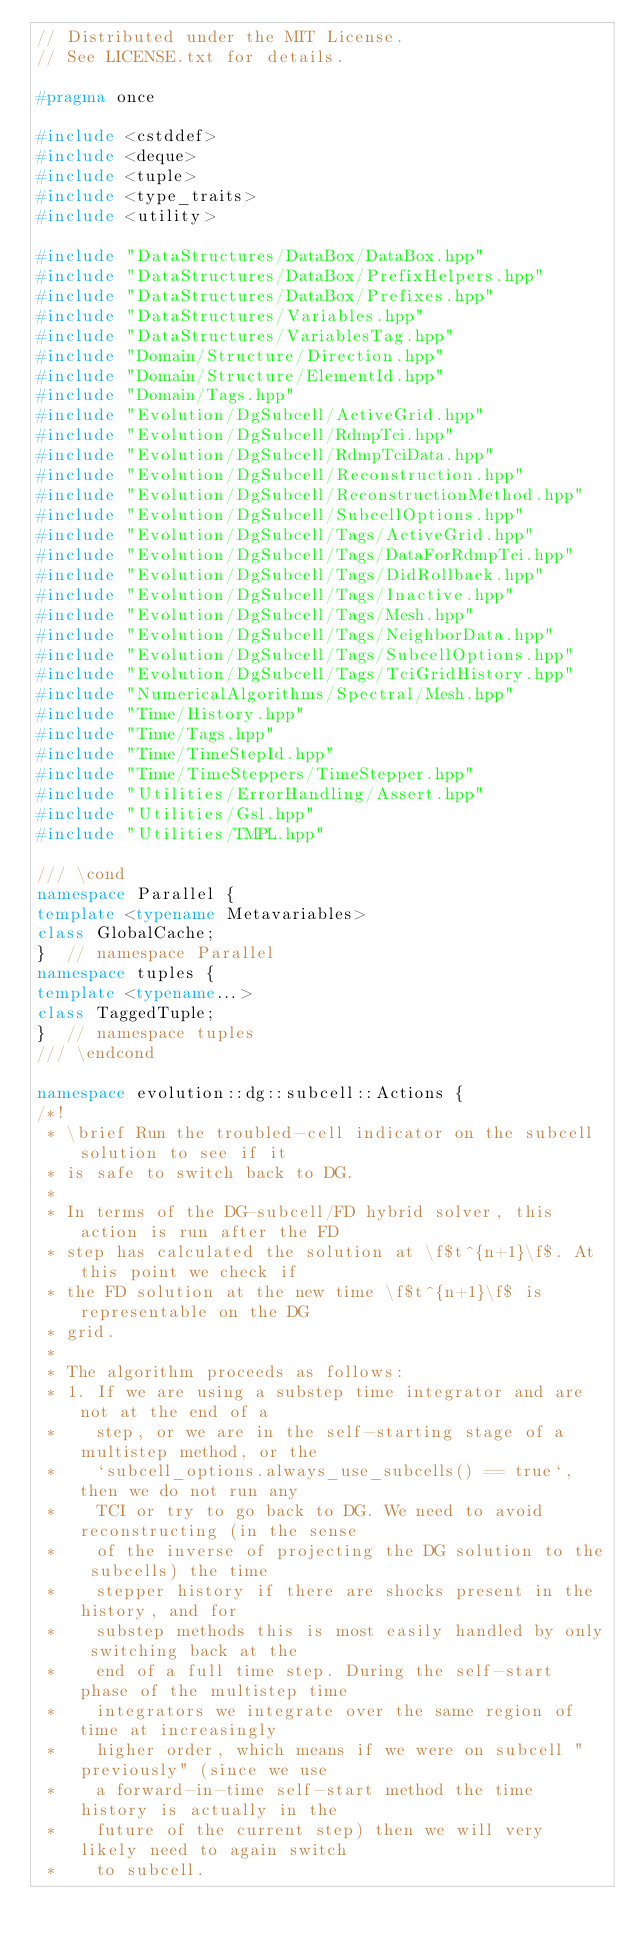<code> <loc_0><loc_0><loc_500><loc_500><_C++_>// Distributed under the MIT License.
// See LICENSE.txt for details.

#pragma once

#include <cstddef>
#include <deque>
#include <tuple>
#include <type_traits>
#include <utility>

#include "DataStructures/DataBox/DataBox.hpp"
#include "DataStructures/DataBox/PrefixHelpers.hpp"
#include "DataStructures/DataBox/Prefixes.hpp"
#include "DataStructures/Variables.hpp"
#include "DataStructures/VariablesTag.hpp"
#include "Domain/Structure/Direction.hpp"
#include "Domain/Structure/ElementId.hpp"
#include "Domain/Tags.hpp"
#include "Evolution/DgSubcell/ActiveGrid.hpp"
#include "Evolution/DgSubcell/RdmpTci.hpp"
#include "Evolution/DgSubcell/RdmpTciData.hpp"
#include "Evolution/DgSubcell/Reconstruction.hpp"
#include "Evolution/DgSubcell/ReconstructionMethod.hpp"
#include "Evolution/DgSubcell/SubcellOptions.hpp"
#include "Evolution/DgSubcell/Tags/ActiveGrid.hpp"
#include "Evolution/DgSubcell/Tags/DataForRdmpTci.hpp"
#include "Evolution/DgSubcell/Tags/DidRollback.hpp"
#include "Evolution/DgSubcell/Tags/Inactive.hpp"
#include "Evolution/DgSubcell/Tags/Mesh.hpp"
#include "Evolution/DgSubcell/Tags/NeighborData.hpp"
#include "Evolution/DgSubcell/Tags/SubcellOptions.hpp"
#include "Evolution/DgSubcell/Tags/TciGridHistory.hpp"
#include "NumericalAlgorithms/Spectral/Mesh.hpp"
#include "Time/History.hpp"
#include "Time/Tags.hpp"
#include "Time/TimeStepId.hpp"
#include "Time/TimeSteppers/TimeStepper.hpp"
#include "Utilities/ErrorHandling/Assert.hpp"
#include "Utilities/Gsl.hpp"
#include "Utilities/TMPL.hpp"

/// \cond
namespace Parallel {
template <typename Metavariables>
class GlobalCache;
}  // namespace Parallel
namespace tuples {
template <typename...>
class TaggedTuple;
}  // namespace tuples
/// \endcond

namespace evolution::dg::subcell::Actions {
/*!
 * \brief Run the troubled-cell indicator on the subcell solution to see if it
 * is safe to switch back to DG.
 *
 * In terms of the DG-subcell/FD hybrid solver, this action is run after the FD
 * step has calculated the solution at \f$t^{n+1}\f$. At this point we check if
 * the FD solution at the new time \f$t^{n+1}\f$ is representable on the DG
 * grid.
 *
 * The algorithm proceeds as follows:
 * 1. If we are using a substep time integrator and are not at the end of a
 *    step, or we are in the self-starting stage of a multistep method, or the
 *    `subcell_options.always_use_subcells() == true`, then we do not run any
 *    TCI or try to go back to DG. We need to avoid reconstructing (in the sense
 *    of the inverse of projecting the DG solution to the subcells) the time
 *    stepper history if there are shocks present in the history, and for
 *    substep methods this is most easily handled by only switching back at the
 *    end of a full time step. During the self-start phase of the multistep time
 *    integrators we integrate over the same region of time at increasingly
 *    higher order, which means if we were on subcell "previously" (since we use
 *    a forward-in-time self-start method the time history is actually in the
 *    future of the current step) then we will very likely need to again switch
 *    to subcell.</code> 